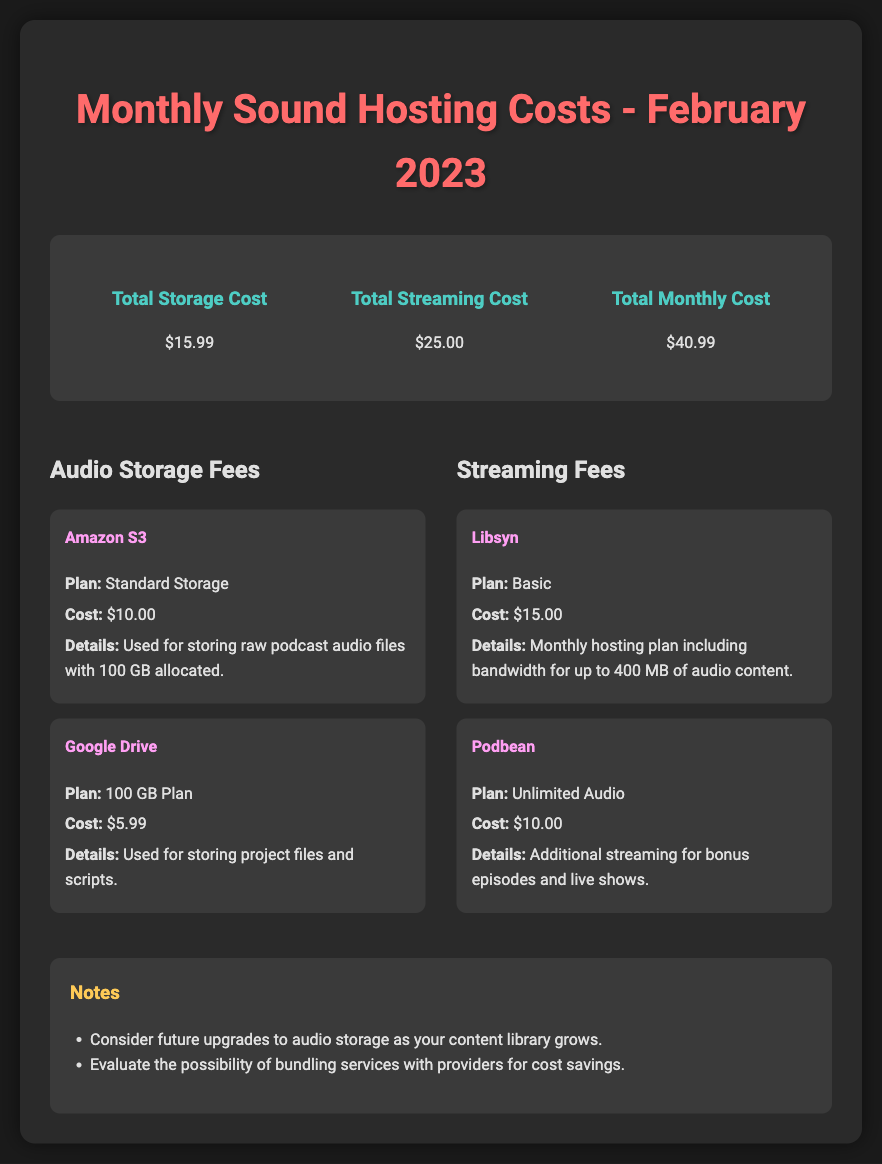What is the total storage cost? The total storage cost is mentioned in the summary section of the document.
Answer: $15.99 What is the cost for Amazon S3? The cost for Amazon S3 is detailed in the audio storage fees section.
Answer: $10.00 What is the plan type for Podbean? The plan type for Podbean is specified in the streaming fees section.
Answer: Unlimited Audio What are the total monthly costs? The total monthly costs are provided in the summary section of the document.
Answer: $40.99 What is the cost for the 100 GB Plan on Google Drive? The cost for the Google Drive plan is found in the audio storage fees breakdown.
Answer: $5.99 How much is the monthly hosting plan with Libsyn? The cost for Libsyn's monthly hosting plan is noted in the streaming fees section.
Answer: $15.00 How many gigabytes are allocated for Amazon S3 storage? The allocation for Amazon S3 storage is mentioned within the details about the service.
Answer: 100 GB What is one consideration mentioned in the notes? The notes section lists considerations for future planning regarding audio storage.
Answer: Future upgrades to audio storage What service is used for storing raw podcast audio files? The specific service used for storing raw podcast audio files is provided in the storage fees breakdown.
Answer: Amazon S3 